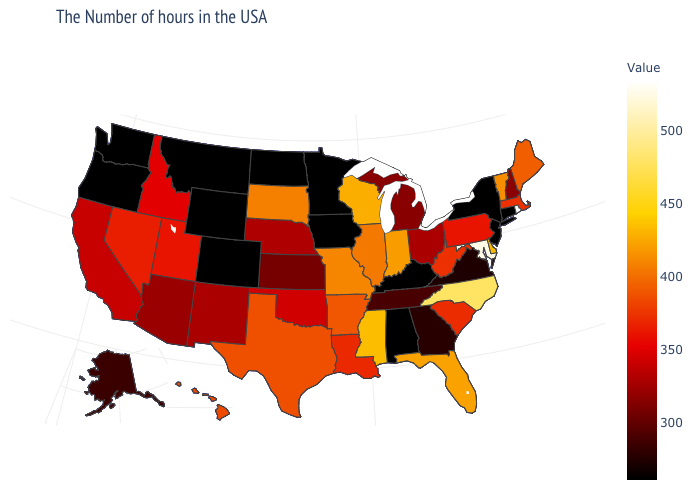Is the legend a continuous bar?
Short answer required. Yes. Does the map have missing data?
Quick response, please. No. Does Massachusetts have a lower value than North Carolina?
Concise answer only. Yes. 